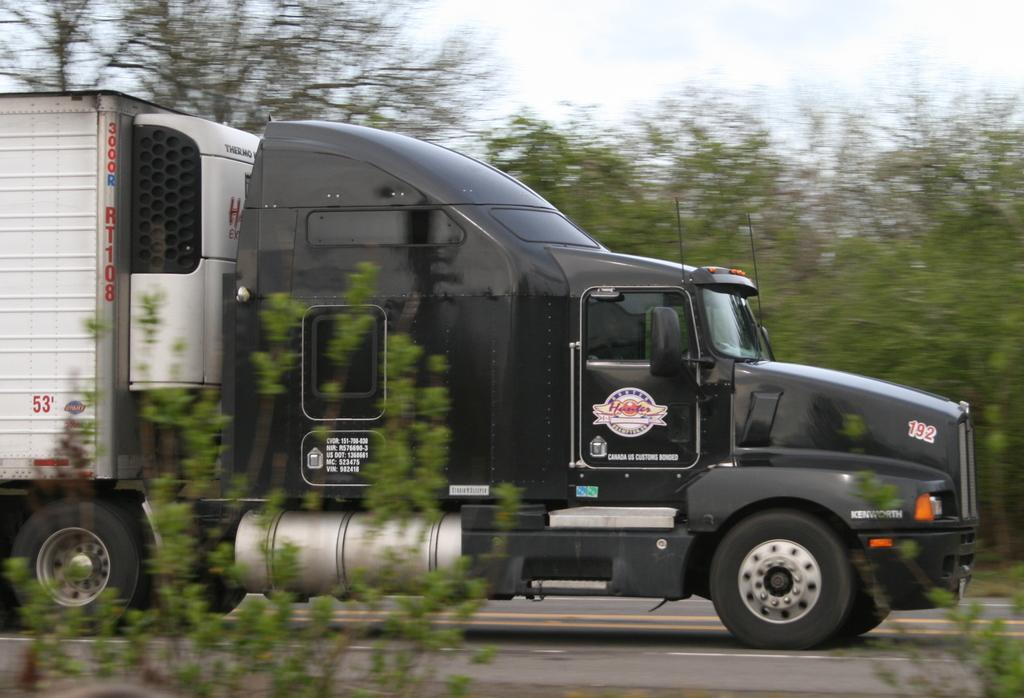What type of vehicle is on the road in the image? There is a truck on the road in the image. What can be seen at the bottom of the image? Plants are visible at the bottom of the image. What is in the background of the image? There are many trees in the background of the image. What is visible at the top of the image? The sky is visible at the top of the image. What can be observed in the sky? Clouds are present in the sky. What color is the crayon used to draw the coastline in the image? There is no coastline or crayon present in the image. 